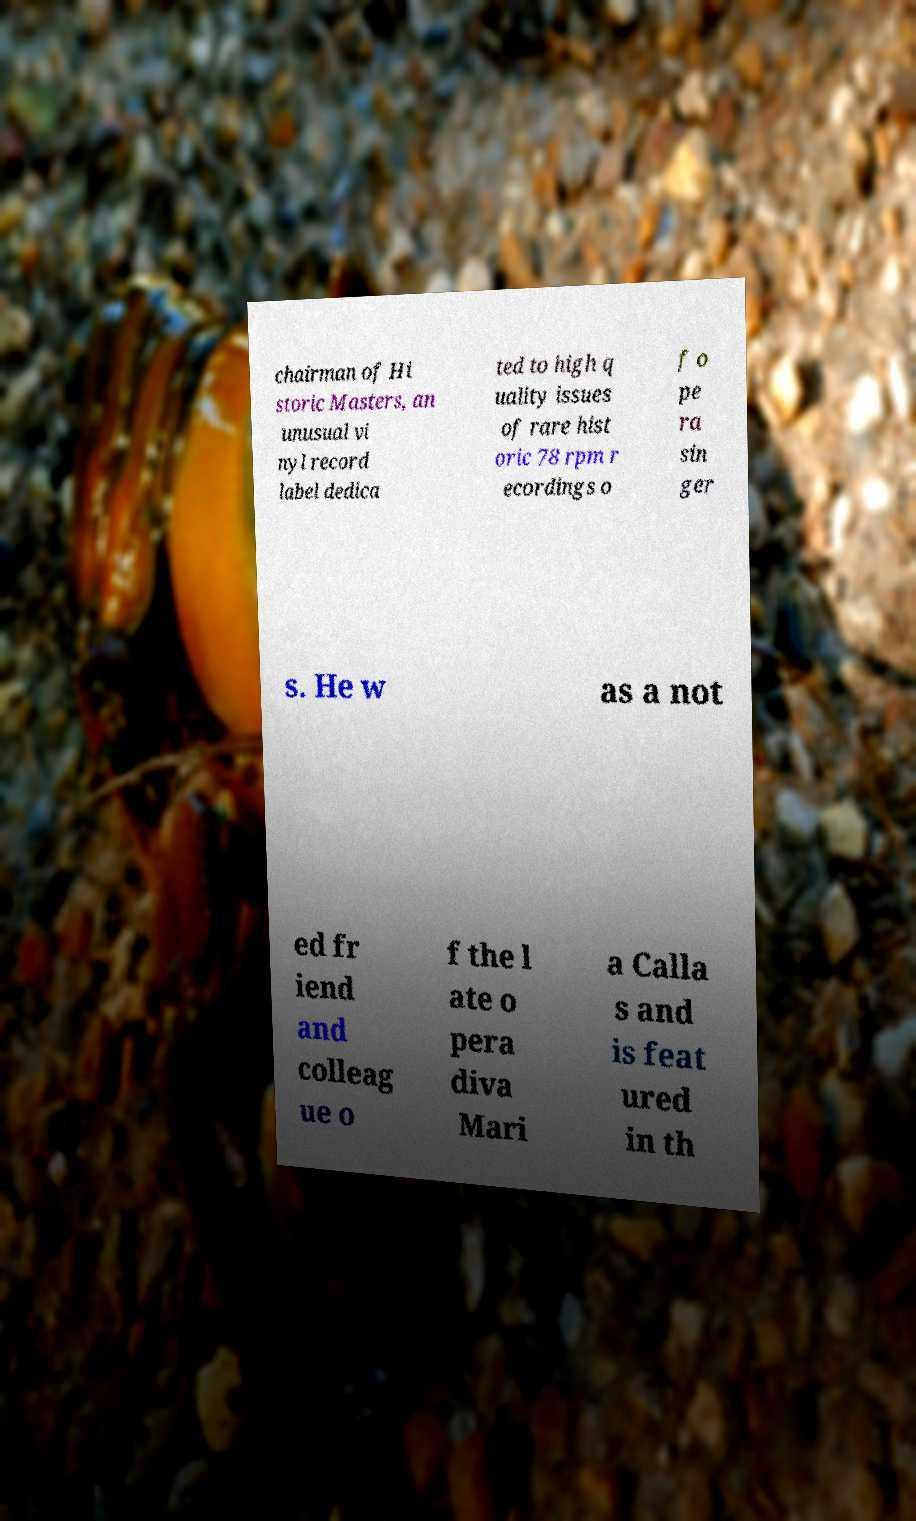Could you extract and type out the text from this image? chairman of Hi storic Masters, an unusual vi nyl record label dedica ted to high q uality issues of rare hist oric 78 rpm r ecordings o f o pe ra sin ger s. He w as a not ed fr iend and colleag ue o f the l ate o pera diva Mari a Calla s and is feat ured in th 